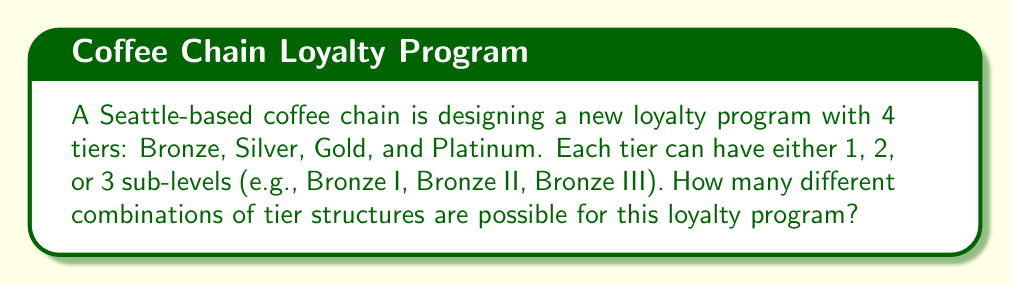What is the answer to this math problem? Let's approach this step-by-step:

1) We have 4 tiers: Bronze, Silver, Gold, and Platinum.

2) For each tier, we have 3 choices: 1, 2, or 3 sub-levels.

3) This is a case of independent events, where the choice for each tier doesn't affect the others.

4) When we have independent events, we multiply the number of possibilities for each event.

5) In this case, we have 4 independent choices (one for each tier), and each choice has 3 possibilities.

6) Therefore, we can use the multiplication principle:

   $$ \text{Total combinations} = 3 \times 3 \times 3 \times 3 $$

7) This can be written as an exponent:

   $$ \text{Total combinations} = 3^4 $$

8) Calculating this:

   $$ 3^4 = 3 \times 3 \times 3 \times 3 = 81 $$

Thus, there are 81 possible combinations for the loyalty program tier structure.
Answer: 81 